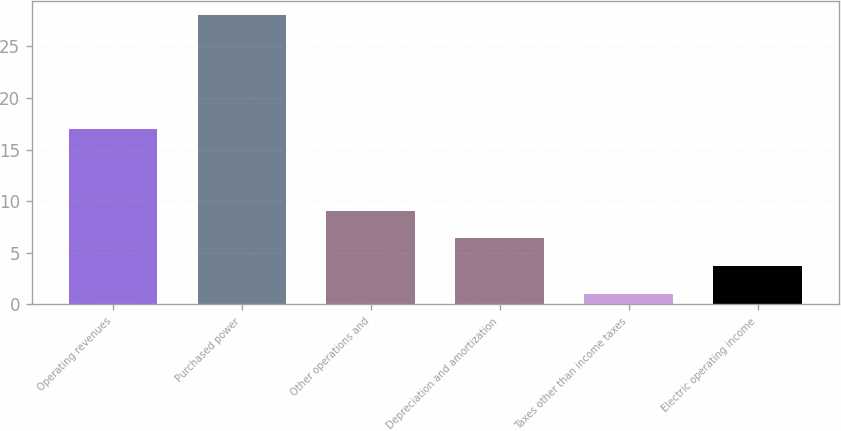Convert chart to OTSL. <chart><loc_0><loc_0><loc_500><loc_500><bar_chart><fcel>Operating revenues<fcel>Purchased power<fcel>Other operations and<fcel>Depreciation and amortization<fcel>Taxes other than income taxes<fcel>Electric operating income<nl><fcel>17<fcel>28<fcel>9.1<fcel>6.4<fcel>1<fcel>3.7<nl></chart> 